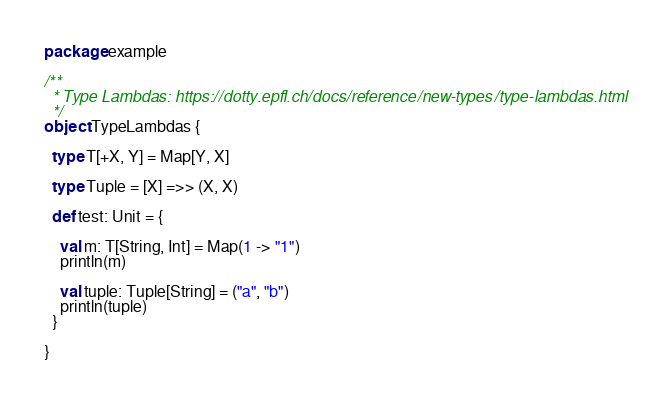Convert code to text. <code><loc_0><loc_0><loc_500><loc_500><_Scala_>package example

/**
  * Type Lambdas: https://dotty.epfl.ch/docs/reference/new-types/type-lambdas.html
  */
object TypeLambdas {

  type T[+X, Y] = Map[Y, X]

  type Tuple = [X] =>> (X, X)

  def test: Unit = {

    val m: T[String, Int] = Map(1 -> "1")
    println(m)

    val tuple: Tuple[String] = ("a", "b")
    println(tuple)
  }

}
</code> 